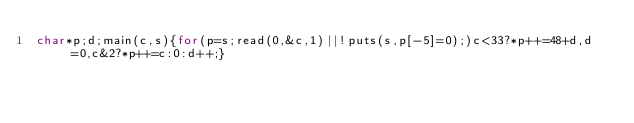<code> <loc_0><loc_0><loc_500><loc_500><_C_>char*p;d;main(c,s){for(p=s;read(0,&c,1)||!puts(s,p[-5]=0);)c<33?*p++=48+d,d=0,c&2?*p++=c:0:d++;}</code> 